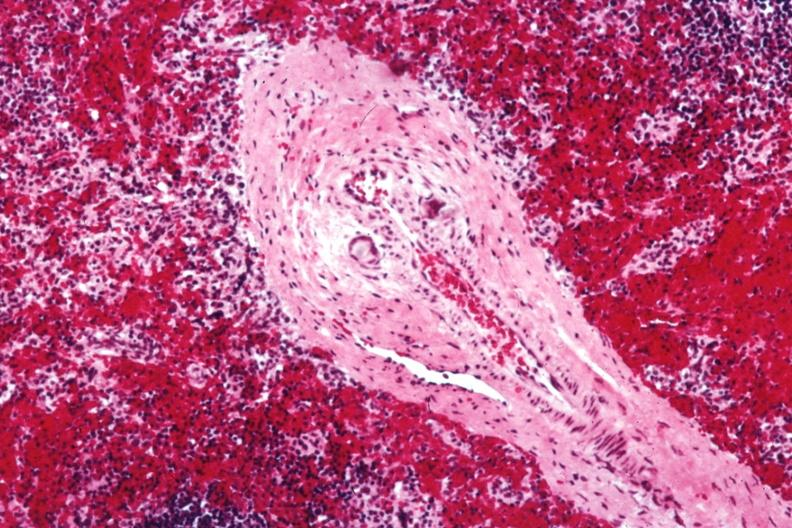does this image show med artery with giant cells in wall containing crystalline material postoperative cardiac surgery thought to be silicon?
Answer the question using a single word or phrase. Yes 